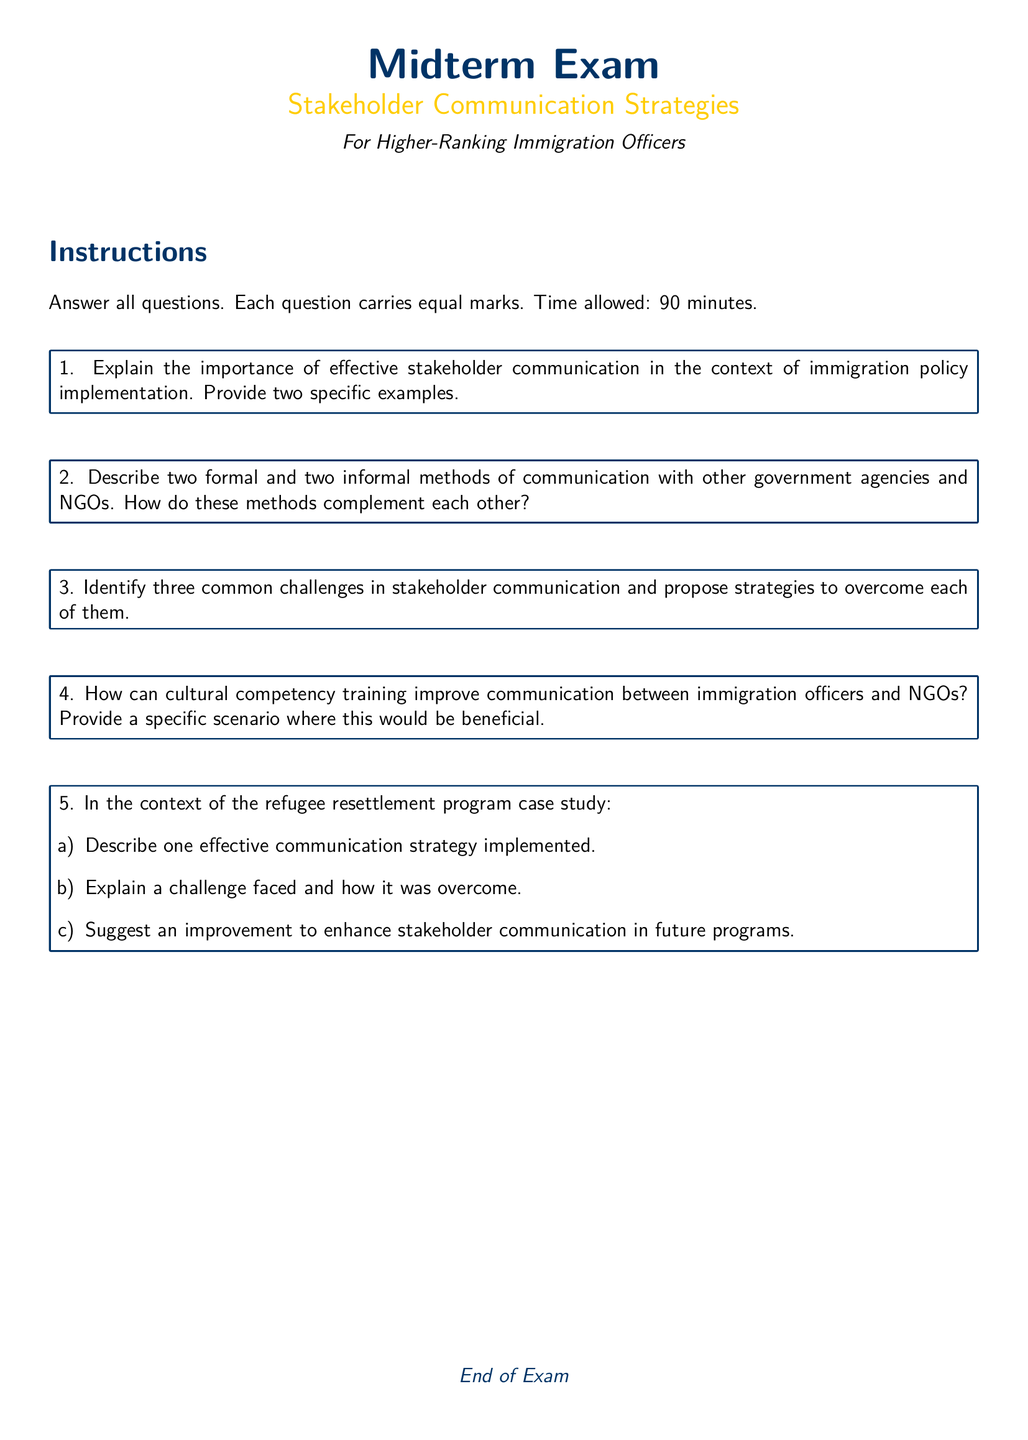What is the title of the document? The title of the document, as indicated in the center, is "Midterm Exam."
Answer: Midterm Exam What is the main focus of the midterm exam? The main focus of the midterm exam is stated directly under the title, highlighting "Stakeholder Communication Strategies."
Answer: Stakeholder Communication Strategies How many questions are there in the exam? The document specifically lists five questions to be answered by the candidates.
Answer: 5 What is the time allowed for the exam? The document specifies that the time allowed for completing the exam is 90 minutes.
Answer: 90 minutes What type of training is mentioned in relation to improving communication? The document refers to "cultural competency training" as a way to enhance communication.
Answer: cultural competency training What is a requirement for answering the questions? The instructions state that all questions must be answered, indicating a necessity for completion.
Answer: Answer all questions What is the color code for the main text color used in the document? The main text color is defined in the document as "RGB(0,51,102)."
Answer: RGB(0,51,102) What format should the responses be in according to the instructions? The instructions do not specify a detailed format, but imply that responses should be complete answers to each question.
Answer: Complete answers What is one of the specific focuses of the challenges in stakeholder communication? The document asks for the identification of "three common challenges" faced in stakeholder communication.
Answer: three common challenges 